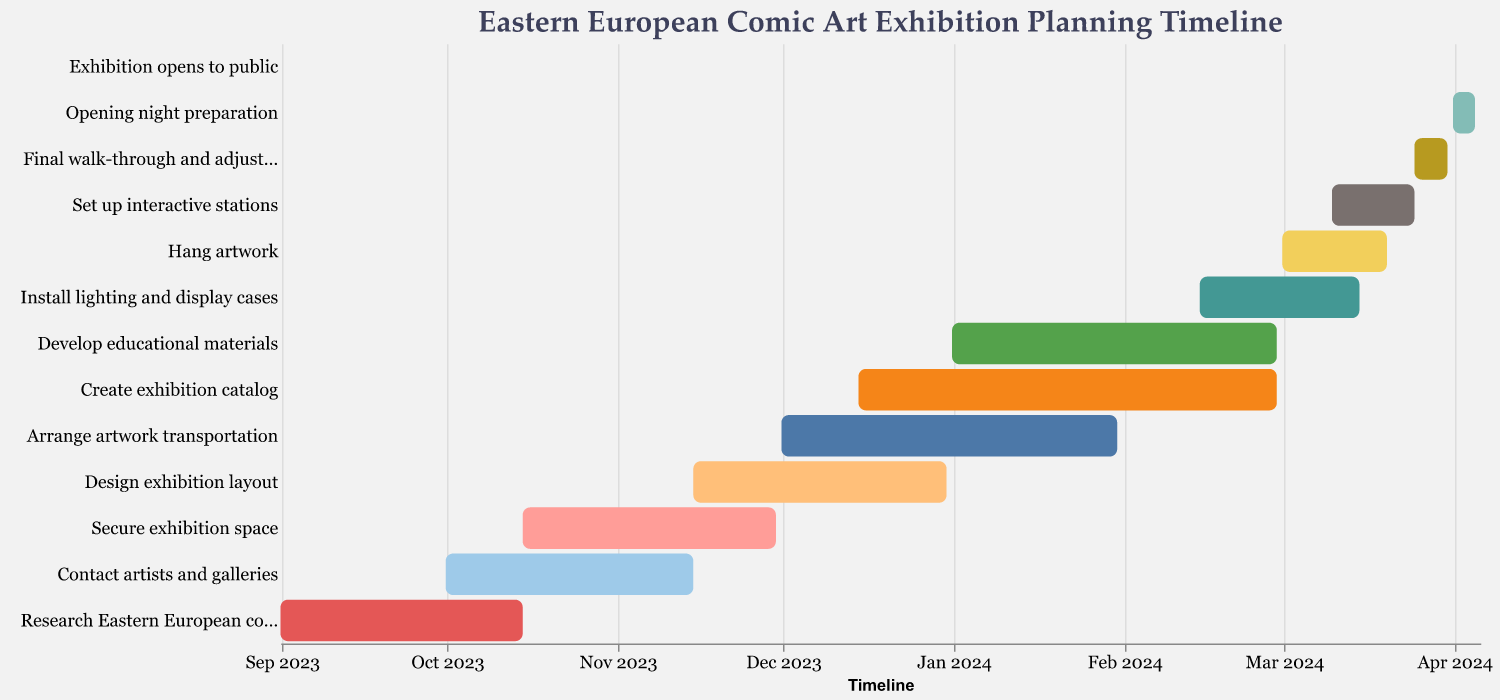What is the title of the Gantt chart? The title is usually shown at the top of the Gantt chart. For this chart, it is prominently displayed to provide context.
Answer: Eastern European Comic Art Exhibition Planning Timeline What is the time span for contacting artists and galleries? To find the time span, look at the start and end dates of the "Contact artists and galleries" task.
Answer: 2023-10-01 to 2023-11-15 Which task starts immediately after "Research Eastern European comic artists"? Check the end date of "Research Eastern European comic artists" and compare it to the start dates of other tasks. The next task that immediately follows is evident.
Answer: Contact artists and galleries How many tasks are set to begin in December 2023? Review the start dates for December 2023 within the Gantt chart. Count the tasks beginning in that month.
Answer: 3 (Arrange artwork transportation, Create exhibition catalog, Design exhibition layout) What is the duration of the task "Arrange artwork transportation"? Find the "Arrange artwork transportation" task and calculate the difference between its start and end date.
Answer: 2 months (from 2023-12-01 to 2024-01-31) Which task has the shortest duration and what is it? To determine the shortest duration task, compare the start and end dates for each task and identify the one with the smallest difference.
Answer: Exhibition opens to public (1 day) How many tasks overlap with "Secure exhibition space"? Check the Gantt chart for tasks that have dates within the range of the "Secure exhibition space" task's start and end dates.
Answer: 2 (Contact artists and galleries, Design exhibition layout) Which tasks are ongoing during March 2024? Identify tasks that have dates within the month of March 2024 by cross-referencing the start and end dates.
Answer: Install lighting and display cases, Hang artwork, Set up interactive stations, Final walk-through and adjustments When does the task "Final walk-through and adjustments" start and end? Find the "Final walk-through and adjustments" task and note its start and end dates.
Answer: 2024-03-25 to 2024-03-31 Which tasks need to be completed before February 2024? Any tasks that end before February 2024 can be identified by checking their end dates against the specified period.
Answer: Research Eastern European comic artists, Contact artists and galleries, Secure exhibition space, Design exhibition layout, Arrange artwork transportation 